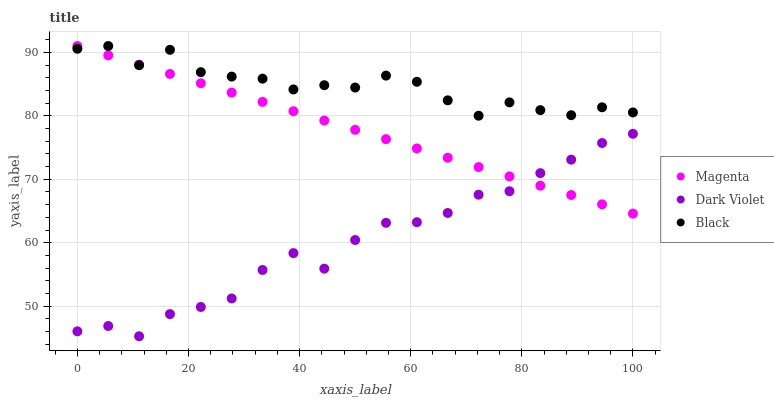Does Dark Violet have the minimum area under the curve?
Answer yes or no. Yes. Does Black have the maximum area under the curve?
Answer yes or no. Yes. Does Black have the minimum area under the curve?
Answer yes or no. No. Does Dark Violet have the maximum area under the curve?
Answer yes or no. No. Is Magenta the smoothest?
Answer yes or no. Yes. Is Black the roughest?
Answer yes or no. Yes. Is Dark Violet the smoothest?
Answer yes or no. No. Is Dark Violet the roughest?
Answer yes or no. No. Does Dark Violet have the lowest value?
Answer yes or no. Yes. Does Black have the lowest value?
Answer yes or no. No. Does Black have the highest value?
Answer yes or no. Yes. Does Dark Violet have the highest value?
Answer yes or no. No. Is Dark Violet less than Black?
Answer yes or no. Yes. Is Black greater than Dark Violet?
Answer yes or no. Yes. Does Magenta intersect Dark Violet?
Answer yes or no. Yes. Is Magenta less than Dark Violet?
Answer yes or no. No. Is Magenta greater than Dark Violet?
Answer yes or no. No. Does Dark Violet intersect Black?
Answer yes or no. No. 